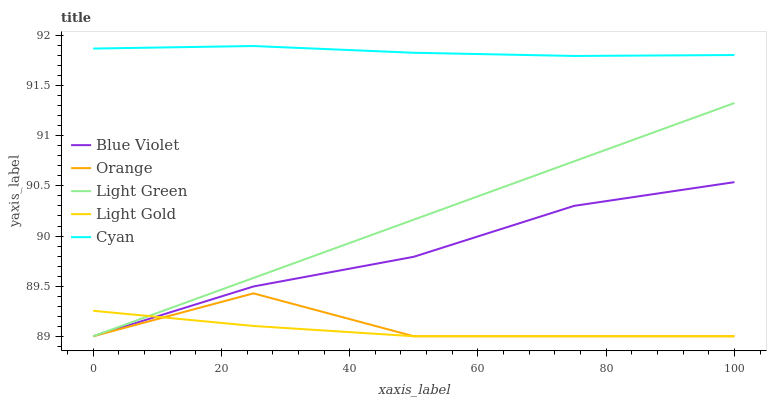Does Light Gold have the minimum area under the curve?
Answer yes or no. Yes. Does Cyan have the maximum area under the curve?
Answer yes or no. Yes. Does Cyan have the minimum area under the curve?
Answer yes or no. No. Does Light Gold have the maximum area under the curve?
Answer yes or no. No. Is Light Green the smoothest?
Answer yes or no. Yes. Is Orange the roughest?
Answer yes or no. Yes. Is Cyan the smoothest?
Answer yes or no. No. Is Cyan the roughest?
Answer yes or no. No. Does Orange have the lowest value?
Answer yes or no. Yes. Does Cyan have the lowest value?
Answer yes or no. No. Does Cyan have the highest value?
Answer yes or no. Yes. Does Light Gold have the highest value?
Answer yes or no. No. Is Orange less than Cyan?
Answer yes or no. Yes. Is Cyan greater than Light Gold?
Answer yes or no. Yes. Does Blue Violet intersect Orange?
Answer yes or no. Yes. Is Blue Violet less than Orange?
Answer yes or no. No. Is Blue Violet greater than Orange?
Answer yes or no. No. Does Orange intersect Cyan?
Answer yes or no. No. 